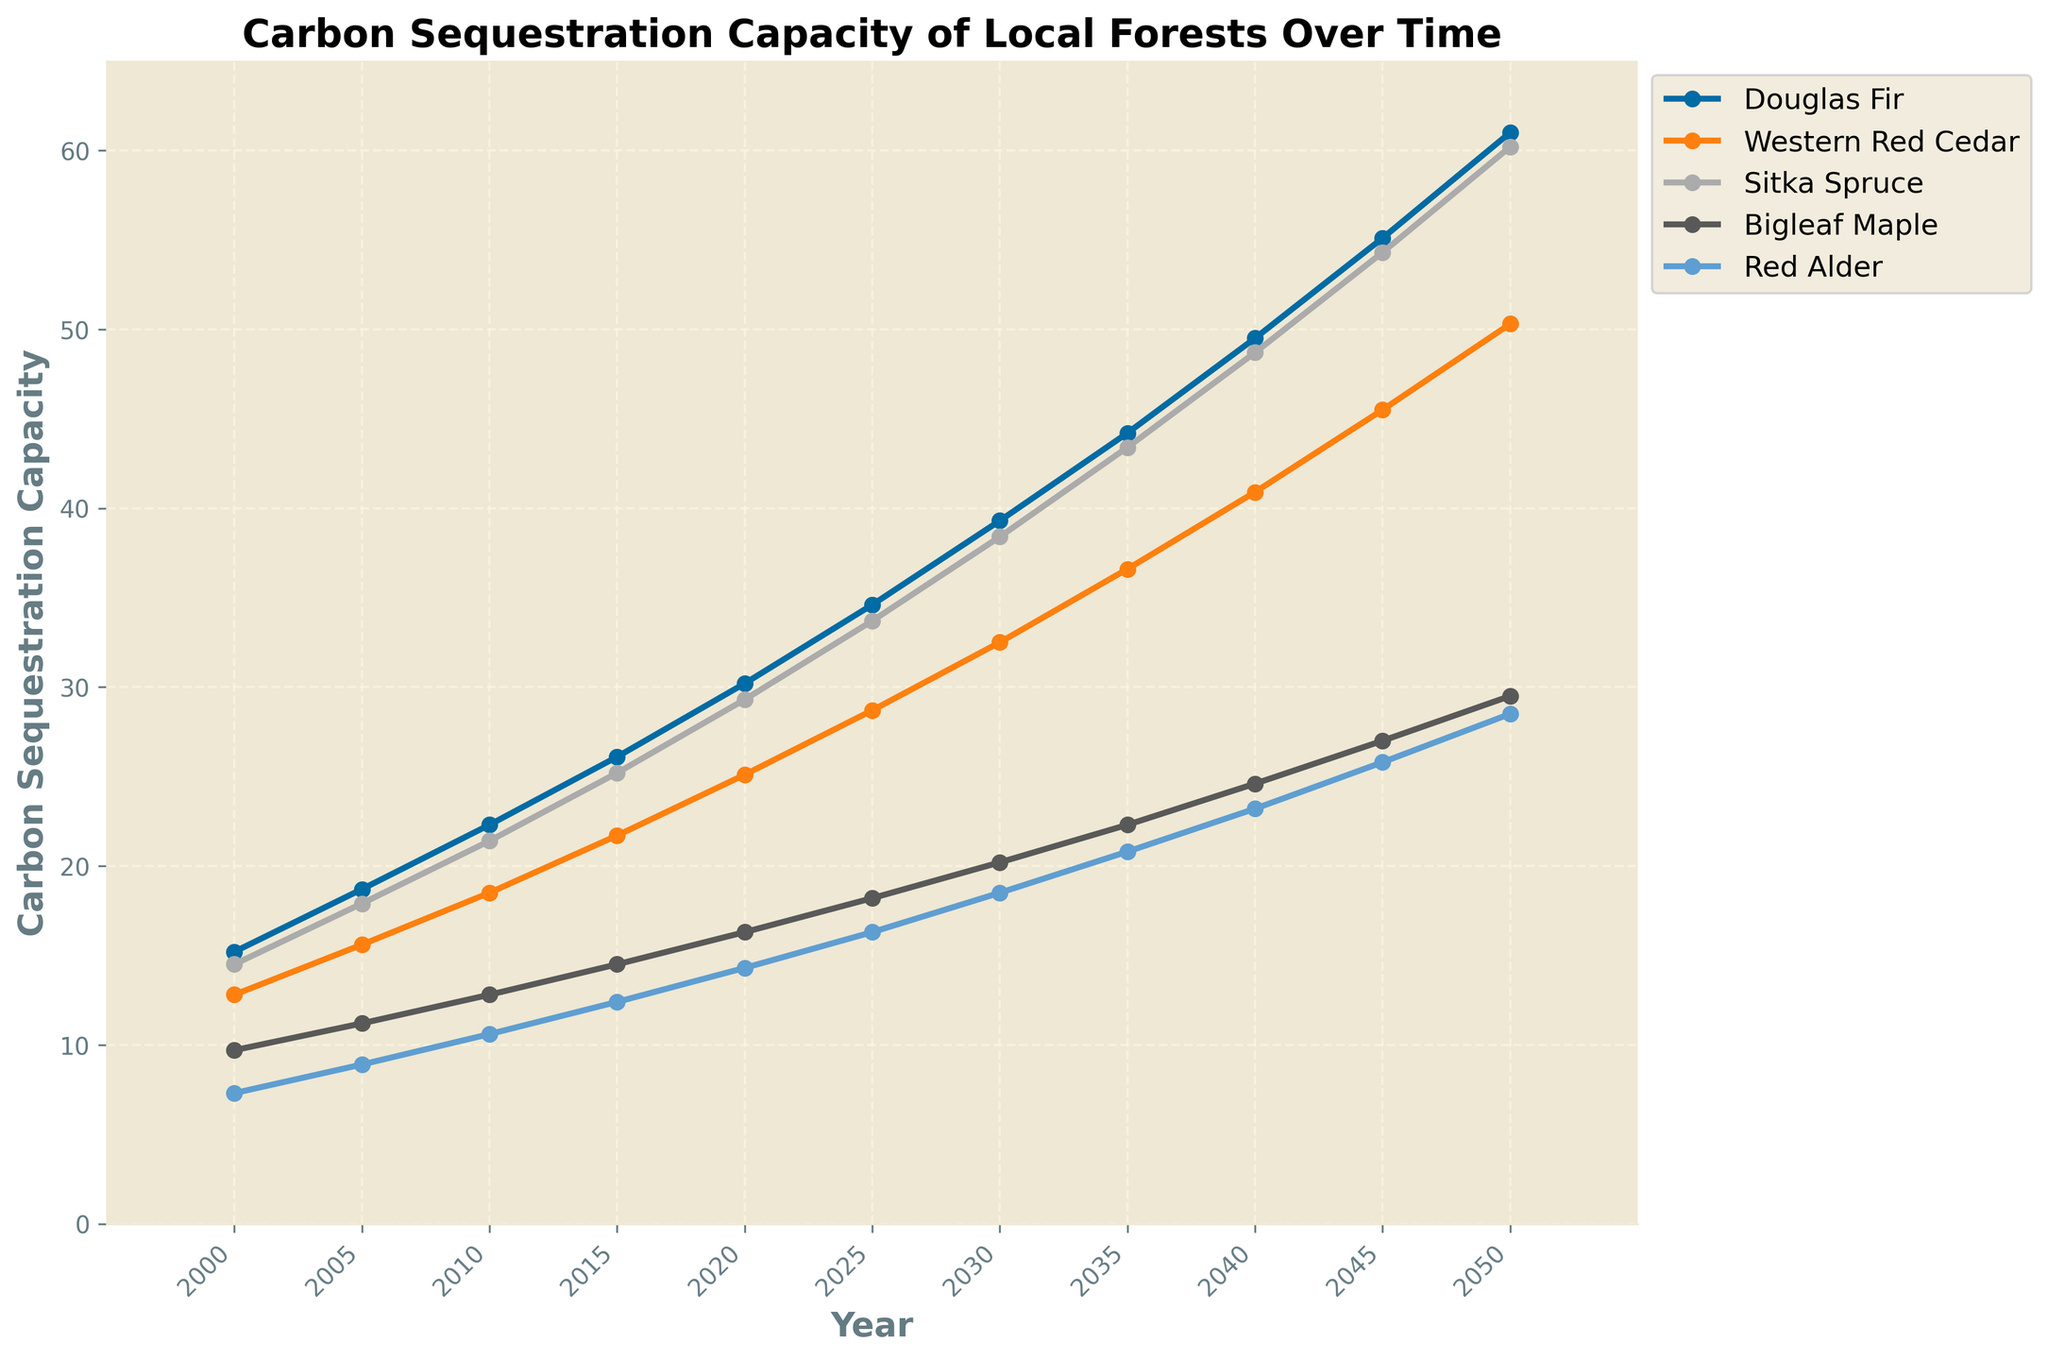Which tree species shows the highest carbon sequestration capacity in 2050? To identify this, we look at the endpoint in 2050 for all the tree species represented by lines on the graph. The line that ends at the highest point on the vertical axis represents the tree with the highest carbon sequestration. Douglas Fir reaches approximately 61 units.
Answer: Douglas Fir How much more carbon does the Sitka Spruce sequester than the Western Red Cedar in 2040? We check the carbon sequestration values for Sitka Spruce and Western Red Cedar in 2040 from the plot, which are around 48.7 and 40.9 respectively. We then subtract the Western Red Cedar value from the Sitka Spruce value: 48.7 - 40.9 = 7.8 units.
Answer: 7.8 units What is the average carbon sequestration capacity of Bigleaf Maple from 2000 to 2050? To find the average, we sum the carbon sequestration capacities of Bigleaf Maple over the years 2000 to 2050 and then divide by the number of data points. The values are 9.7, 11.2, 12.8, 14.5, 16.3, 18.2, 20.2, 22.3, 24.6, 27.0, 29.5. The total is 186.3, and there are 11 data points, so the average is 186.3 / 11 = 16.94 units.
Answer: 16.94 units Between which years does the Douglas Fir show the largest increase in carbon sequestration capacity? We examine the differences in Douglas Fir's carbon sequestration over consecutive five-year intervals. The largest increment is from 2000 to 2005, 2005 to 2010, and so on. The increments are 3.5, 3.6, 3.8, 4.1, 4.4, 4.7, 4.9, 5.3, 5.6, and 5.9 units. The largest increase is 5.9 units between 2045 and 2050.
Answer: 2045 to 2050 Compare the trends of carbon sequestration between Bigleaf Maple and Red Alder. Which species has a steeper increase over time? By observing the slopes of the lines representing Bigleaf Maple and Red Alder from 2000 to 2050, we note that Bigleaf Maple's line has a steeper curve, indicating a more rapid increase compared to Red Alder.
Answer: Bigleaf Maple What is the difference in carbon sequestration between the highest and lowest species in 2000? From the graph, Douglas Fir is the highest in 2000 with 15.2 units and Red Alder the lowest with 7.3 units. The difference is calculated as 15.2 - 7.3 = 7.9 units.
Answer: 7.9 units Which tree species shows the smallest relative increase in carbon sequestration capacity from 2000 to 2050? To find this, we look at the proportional increase for each tree species. We calculate the relative increase as (value in 2050 - value in 2000) / value in 2000. Red Alder starts at 7.3 and ends at 28.5: (28.5 - 7.3) / 7.3 = 2.9. Comparing relative increases, Red Alder shows the smallest increase.
Answer: Red Alder At what year do Sitka Spruce and Western Red Cedar have roughly equal carbon sequestration capacity? We observe the graph to find the year where the lines for Sitka Spruce and Western Red Cedar intersect or are closest. This appears to occur around 2010, where both are approximately 21.4 and 21.7 units, respectively.
Answer: 2010 